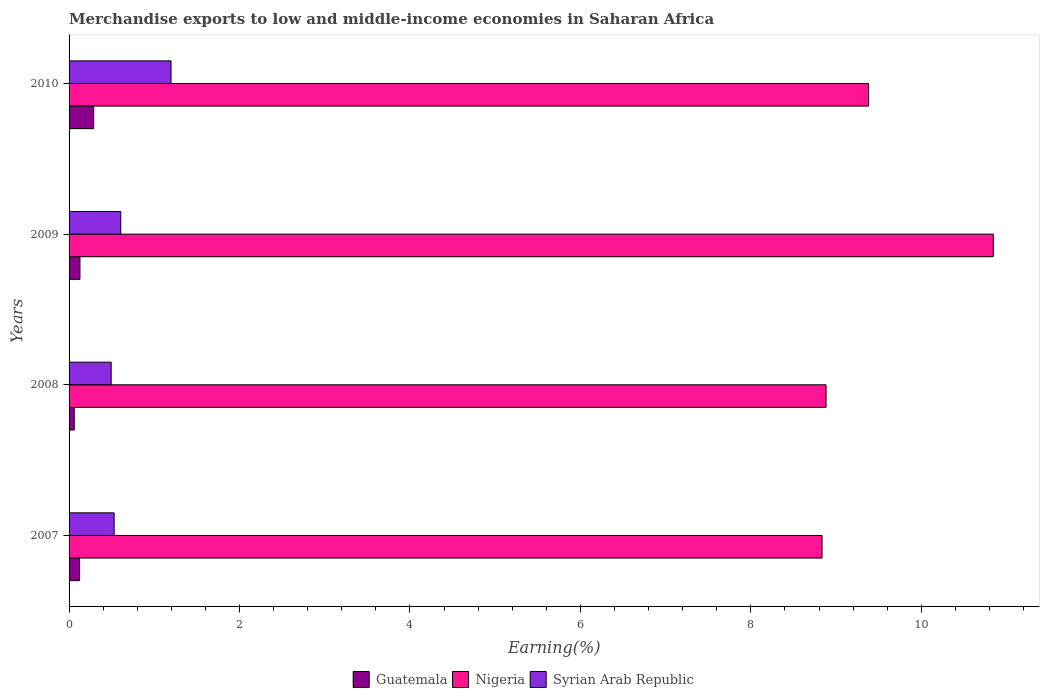How many different coloured bars are there?
Your answer should be compact. 3. How many bars are there on the 3rd tick from the top?
Provide a short and direct response. 3. What is the percentage of amount earned from merchandise exports in Nigeria in 2007?
Keep it short and to the point. 8.83. Across all years, what is the maximum percentage of amount earned from merchandise exports in Guatemala?
Provide a succinct answer. 0.29. Across all years, what is the minimum percentage of amount earned from merchandise exports in Syrian Arab Republic?
Your answer should be compact. 0.49. What is the total percentage of amount earned from merchandise exports in Nigeria in the graph?
Provide a succinct answer. 37.94. What is the difference between the percentage of amount earned from merchandise exports in Syrian Arab Republic in 2007 and that in 2009?
Offer a terse response. -0.08. What is the difference between the percentage of amount earned from merchandise exports in Guatemala in 2010 and the percentage of amount earned from merchandise exports in Nigeria in 2007?
Provide a short and direct response. -8.55. What is the average percentage of amount earned from merchandise exports in Guatemala per year?
Provide a short and direct response. 0.15. In the year 2010, what is the difference between the percentage of amount earned from merchandise exports in Guatemala and percentage of amount earned from merchandise exports in Nigeria?
Make the answer very short. -9.09. What is the ratio of the percentage of amount earned from merchandise exports in Guatemala in 2007 to that in 2008?
Make the answer very short. 2.02. Is the percentage of amount earned from merchandise exports in Nigeria in 2007 less than that in 2008?
Keep it short and to the point. Yes. Is the difference between the percentage of amount earned from merchandise exports in Guatemala in 2007 and 2010 greater than the difference between the percentage of amount earned from merchandise exports in Nigeria in 2007 and 2010?
Offer a very short reply. Yes. What is the difference between the highest and the second highest percentage of amount earned from merchandise exports in Nigeria?
Provide a short and direct response. 1.46. What is the difference between the highest and the lowest percentage of amount earned from merchandise exports in Syrian Arab Republic?
Offer a terse response. 0.7. What does the 1st bar from the top in 2009 represents?
Ensure brevity in your answer.  Syrian Arab Republic. What does the 2nd bar from the bottom in 2009 represents?
Offer a very short reply. Nigeria. How many years are there in the graph?
Keep it short and to the point. 4. Does the graph contain any zero values?
Make the answer very short. No. How many legend labels are there?
Offer a very short reply. 3. How are the legend labels stacked?
Give a very brief answer. Horizontal. What is the title of the graph?
Keep it short and to the point. Merchandise exports to low and middle-income economies in Saharan Africa. Does "Saudi Arabia" appear as one of the legend labels in the graph?
Provide a succinct answer. No. What is the label or title of the X-axis?
Provide a succinct answer. Earning(%). What is the label or title of the Y-axis?
Offer a terse response. Years. What is the Earning(%) of Guatemala in 2007?
Provide a short and direct response. 0.12. What is the Earning(%) of Nigeria in 2007?
Keep it short and to the point. 8.83. What is the Earning(%) in Syrian Arab Republic in 2007?
Offer a very short reply. 0.53. What is the Earning(%) in Guatemala in 2008?
Provide a succinct answer. 0.06. What is the Earning(%) of Nigeria in 2008?
Your answer should be compact. 8.88. What is the Earning(%) in Syrian Arab Republic in 2008?
Offer a very short reply. 0.49. What is the Earning(%) of Guatemala in 2009?
Offer a terse response. 0.13. What is the Earning(%) in Nigeria in 2009?
Offer a terse response. 10.84. What is the Earning(%) in Syrian Arab Republic in 2009?
Keep it short and to the point. 0.61. What is the Earning(%) of Guatemala in 2010?
Make the answer very short. 0.29. What is the Earning(%) of Nigeria in 2010?
Provide a succinct answer. 9.38. What is the Earning(%) in Syrian Arab Republic in 2010?
Your response must be concise. 1.2. Across all years, what is the maximum Earning(%) in Guatemala?
Ensure brevity in your answer.  0.29. Across all years, what is the maximum Earning(%) in Nigeria?
Make the answer very short. 10.84. Across all years, what is the maximum Earning(%) in Syrian Arab Republic?
Keep it short and to the point. 1.2. Across all years, what is the minimum Earning(%) in Guatemala?
Offer a terse response. 0.06. Across all years, what is the minimum Earning(%) of Nigeria?
Give a very brief answer. 8.83. Across all years, what is the minimum Earning(%) of Syrian Arab Republic?
Ensure brevity in your answer.  0.49. What is the total Earning(%) in Guatemala in the graph?
Make the answer very short. 0.6. What is the total Earning(%) of Nigeria in the graph?
Make the answer very short. 37.94. What is the total Earning(%) in Syrian Arab Republic in the graph?
Make the answer very short. 2.83. What is the difference between the Earning(%) of Guatemala in 2007 and that in 2008?
Ensure brevity in your answer.  0.06. What is the difference between the Earning(%) in Nigeria in 2007 and that in 2008?
Offer a terse response. -0.05. What is the difference between the Earning(%) in Syrian Arab Republic in 2007 and that in 2008?
Your answer should be compact. 0.03. What is the difference between the Earning(%) of Guatemala in 2007 and that in 2009?
Offer a very short reply. -0. What is the difference between the Earning(%) of Nigeria in 2007 and that in 2009?
Your response must be concise. -2.01. What is the difference between the Earning(%) of Syrian Arab Republic in 2007 and that in 2009?
Your response must be concise. -0.08. What is the difference between the Earning(%) of Guatemala in 2007 and that in 2010?
Offer a terse response. -0.17. What is the difference between the Earning(%) in Nigeria in 2007 and that in 2010?
Provide a short and direct response. -0.55. What is the difference between the Earning(%) of Syrian Arab Republic in 2007 and that in 2010?
Give a very brief answer. -0.67. What is the difference between the Earning(%) of Guatemala in 2008 and that in 2009?
Your answer should be compact. -0.07. What is the difference between the Earning(%) of Nigeria in 2008 and that in 2009?
Provide a succinct answer. -1.96. What is the difference between the Earning(%) of Syrian Arab Republic in 2008 and that in 2009?
Provide a short and direct response. -0.11. What is the difference between the Earning(%) of Guatemala in 2008 and that in 2010?
Ensure brevity in your answer.  -0.23. What is the difference between the Earning(%) of Nigeria in 2008 and that in 2010?
Keep it short and to the point. -0.5. What is the difference between the Earning(%) in Syrian Arab Republic in 2008 and that in 2010?
Make the answer very short. -0.7. What is the difference between the Earning(%) in Guatemala in 2009 and that in 2010?
Give a very brief answer. -0.16. What is the difference between the Earning(%) of Nigeria in 2009 and that in 2010?
Give a very brief answer. 1.46. What is the difference between the Earning(%) of Syrian Arab Republic in 2009 and that in 2010?
Provide a succinct answer. -0.59. What is the difference between the Earning(%) in Guatemala in 2007 and the Earning(%) in Nigeria in 2008?
Offer a terse response. -8.76. What is the difference between the Earning(%) in Guatemala in 2007 and the Earning(%) in Syrian Arab Republic in 2008?
Your answer should be compact. -0.37. What is the difference between the Earning(%) in Nigeria in 2007 and the Earning(%) in Syrian Arab Republic in 2008?
Provide a succinct answer. 8.34. What is the difference between the Earning(%) of Guatemala in 2007 and the Earning(%) of Nigeria in 2009?
Keep it short and to the point. -10.72. What is the difference between the Earning(%) of Guatemala in 2007 and the Earning(%) of Syrian Arab Republic in 2009?
Ensure brevity in your answer.  -0.48. What is the difference between the Earning(%) in Nigeria in 2007 and the Earning(%) in Syrian Arab Republic in 2009?
Your answer should be compact. 8.23. What is the difference between the Earning(%) of Guatemala in 2007 and the Earning(%) of Nigeria in 2010?
Ensure brevity in your answer.  -9.26. What is the difference between the Earning(%) in Guatemala in 2007 and the Earning(%) in Syrian Arab Republic in 2010?
Your response must be concise. -1.07. What is the difference between the Earning(%) in Nigeria in 2007 and the Earning(%) in Syrian Arab Republic in 2010?
Offer a terse response. 7.64. What is the difference between the Earning(%) of Guatemala in 2008 and the Earning(%) of Nigeria in 2009?
Offer a very short reply. -10.78. What is the difference between the Earning(%) in Guatemala in 2008 and the Earning(%) in Syrian Arab Republic in 2009?
Offer a terse response. -0.55. What is the difference between the Earning(%) of Nigeria in 2008 and the Earning(%) of Syrian Arab Republic in 2009?
Provide a succinct answer. 8.28. What is the difference between the Earning(%) in Guatemala in 2008 and the Earning(%) in Nigeria in 2010?
Provide a short and direct response. -9.32. What is the difference between the Earning(%) of Guatemala in 2008 and the Earning(%) of Syrian Arab Republic in 2010?
Your response must be concise. -1.14. What is the difference between the Earning(%) of Nigeria in 2008 and the Earning(%) of Syrian Arab Republic in 2010?
Keep it short and to the point. 7.69. What is the difference between the Earning(%) in Guatemala in 2009 and the Earning(%) in Nigeria in 2010?
Keep it short and to the point. -9.25. What is the difference between the Earning(%) in Guatemala in 2009 and the Earning(%) in Syrian Arab Republic in 2010?
Offer a terse response. -1.07. What is the difference between the Earning(%) in Nigeria in 2009 and the Earning(%) in Syrian Arab Republic in 2010?
Your response must be concise. 9.65. What is the average Earning(%) in Guatemala per year?
Ensure brevity in your answer.  0.15. What is the average Earning(%) in Nigeria per year?
Provide a short and direct response. 9.49. What is the average Earning(%) in Syrian Arab Republic per year?
Your answer should be very brief. 0.71. In the year 2007, what is the difference between the Earning(%) of Guatemala and Earning(%) of Nigeria?
Keep it short and to the point. -8.71. In the year 2007, what is the difference between the Earning(%) of Guatemala and Earning(%) of Syrian Arab Republic?
Keep it short and to the point. -0.41. In the year 2007, what is the difference between the Earning(%) of Nigeria and Earning(%) of Syrian Arab Republic?
Give a very brief answer. 8.31. In the year 2008, what is the difference between the Earning(%) of Guatemala and Earning(%) of Nigeria?
Provide a short and direct response. -8.82. In the year 2008, what is the difference between the Earning(%) of Guatemala and Earning(%) of Syrian Arab Republic?
Provide a succinct answer. -0.43. In the year 2008, what is the difference between the Earning(%) in Nigeria and Earning(%) in Syrian Arab Republic?
Your response must be concise. 8.39. In the year 2009, what is the difference between the Earning(%) in Guatemala and Earning(%) in Nigeria?
Offer a terse response. -10.72. In the year 2009, what is the difference between the Earning(%) in Guatemala and Earning(%) in Syrian Arab Republic?
Ensure brevity in your answer.  -0.48. In the year 2009, what is the difference between the Earning(%) of Nigeria and Earning(%) of Syrian Arab Republic?
Offer a terse response. 10.24. In the year 2010, what is the difference between the Earning(%) of Guatemala and Earning(%) of Nigeria?
Your answer should be compact. -9.09. In the year 2010, what is the difference between the Earning(%) of Guatemala and Earning(%) of Syrian Arab Republic?
Provide a short and direct response. -0.91. In the year 2010, what is the difference between the Earning(%) of Nigeria and Earning(%) of Syrian Arab Republic?
Your response must be concise. 8.19. What is the ratio of the Earning(%) of Guatemala in 2007 to that in 2008?
Offer a terse response. 2.02. What is the ratio of the Earning(%) of Nigeria in 2007 to that in 2008?
Ensure brevity in your answer.  0.99. What is the ratio of the Earning(%) of Syrian Arab Republic in 2007 to that in 2008?
Provide a succinct answer. 1.07. What is the ratio of the Earning(%) of Guatemala in 2007 to that in 2009?
Offer a terse response. 0.97. What is the ratio of the Earning(%) of Nigeria in 2007 to that in 2009?
Provide a succinct answer. 0.81. What is the ratio of the Earning(%) of Syrian Arab Republic in 2007 to that in 2009?
Keep it short and to the point. 0.87. What is the ratio of the Earning(%) of Guatemala in 2007 to that in 2010?
Offer a very short reply. 0.43. What is the ratio of the Earning(%) of Nigeria in 2007 to that in 2010?
Your answer should be compact. 0.94. What is the ratio of the Earning(%) of Syrian Arab Republic in 2007 to that in 2010?
Offer a very short reply. 0.44. What is the ratio of the Earning(%) of Guatemala in 2008 to that in 2009?
Ensure brevity in your answer.  0.48. What is the ratio of the Earning(%) in Nigeria in 2008 to that in 2009?
Make the answer very short. 0.82. What is the ratio of the Earning(%) of Syrian Arab Republic in 2008 to that in 2009?
Offer a very short reply. 0.81. What is the ratio of the Earning(%) in Guatemala in 2008 to that in 2010?
Offer a very short reply. 0.21. What is the ratio of the Earning(%) of Nigeria in 2008 to that in 2010?
Offer a terse response. 0.95. What is the ratio of the Earning(%) of Syrian Arab Republic in 2008 to that in 2010?
Offer a very short reply. 0.41. What is the ratio of the Earning(%) in Guatemala in 2009 to that in 2010?
Offer a very short reply. 0.44. What is the ratio of the Earning(%) in Nigeria in 2009 to that in 2010?
Your answer should be compact. 1.16. What is the ratio of the Earning(%) in Syrian Arab Republic in 2009 to that in 2010?
Keep it short and to the point. 0.51. What is the difference between the highest and the second highest Earning(%) of Guatemala?
Provide a succinct answer. 0.16. What is the difference between the highest and the second highest Earning(%) in Nigeria?
Give a very brief answer. 1.46. What is the difference between the highest and the second highest Earning(%) in Syrian Arab Republic?
Make the answer very short. 0.59. What is the difference between the highest and the lowest Earning(%) in Guatemala?
Ensure brevity in your answer.  0.23. What is the difference between the highest and the lowest Earning(%) in Nigeria?
Offer a terse response. 2.01. What is the difference between the highest and the lowest Earning(%) in Syrian Arab Republic?
Make the answer very short. 0.7. 